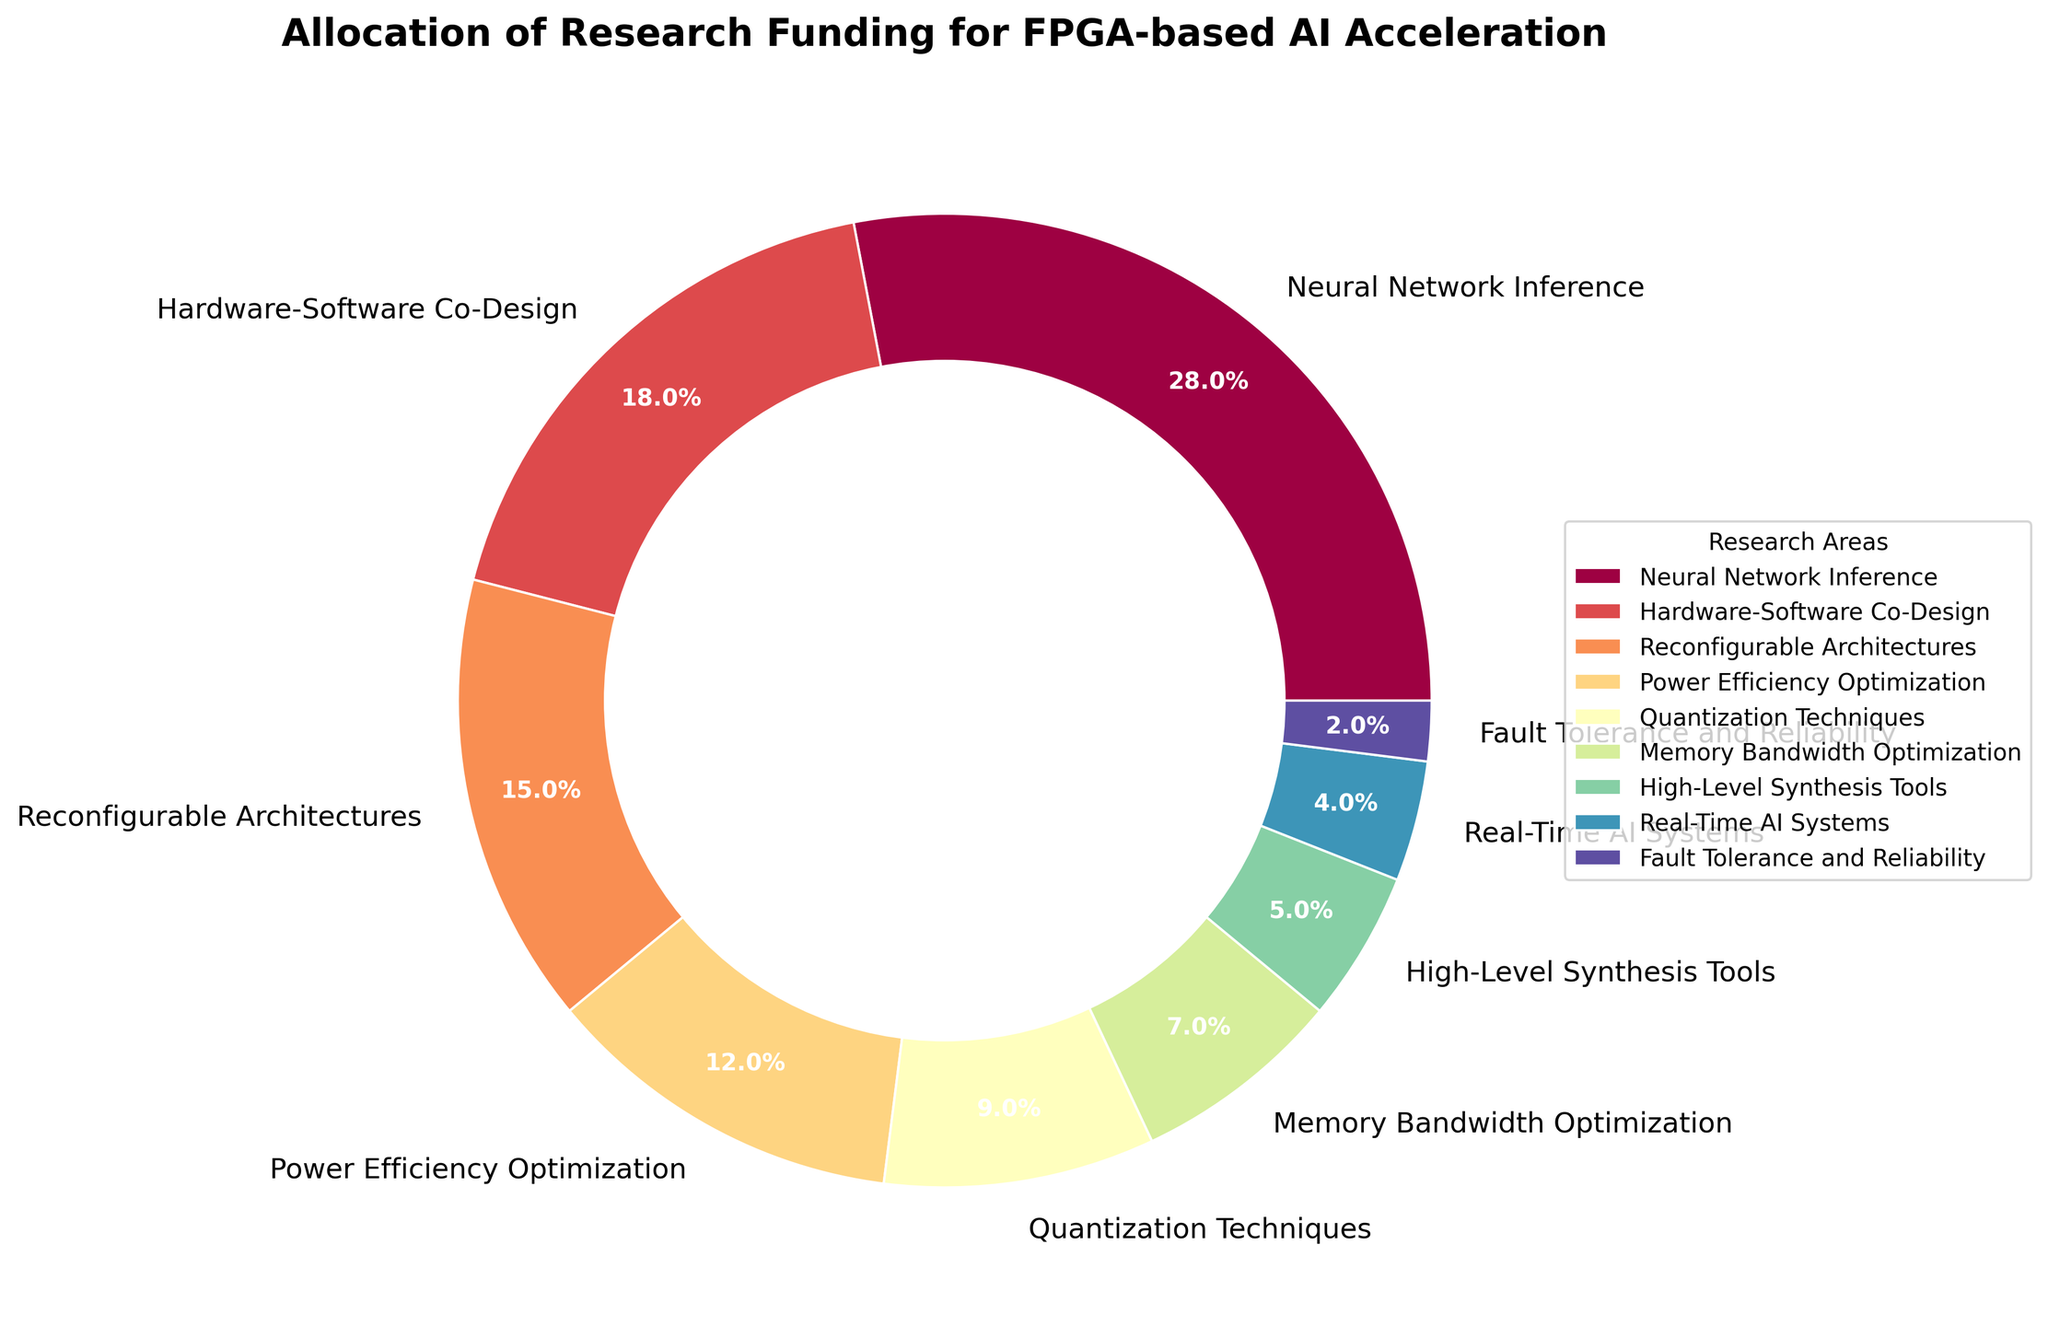what percentage of funding is allocated to Neural Network Inference? Locate the label "Neural Network Inference" on the pie chart and read the corresponding percentage.
Answer: 28% Which research areas combined receive more funding than Neural Network Inference? Add the percentages of the research areas and compare each sum to 28%. "Hardware-Software Co-Design" (18%) and "Reconfigurable Architectures" (15%) together receive 33%, which is greater than 28%. Individual areas "Power Efficiency Optimization" (12%) and below do not meet the requirement when summed alone or in pairs.
Answer: Hardware-Software Co-Design and Reconfigurable Architectures How much more funding is allocated to Memory Bandwidth Optimization compared to Fault Tolerance and Reliability? Subtract the percentage for "Fault Tolerance and Reliability" from that for "Memory Bandwidth Optimization": 7% - 2% = 5%.
Answer: 5% If Real-Time AI Systems and Fault Tolerance and Reliability received a combined total of 10%, how many percentage points are they currently receiving together? Sum the percentages for "Real-Time AI Systems" (4%) and "Fault Tolerance and Reliability" (2%): 4% + 2% = 6%. Compare this to the hypothetical 10%.
Answer: 6% Which research area has the smallest slice on the pie chart? Identify the smallest wedge visually, which belongs to the research area "Fault Tolerance and Reliability" (2%).
Answer: Fault Tolerance and Reliability What is the combined funding allocation percentage for the bottom three research areas? Sum the percentages for the three smallest areas: "High-Level Synthesis Tools" (5%), "Real-Time AI Systems" (4%), and "Fault Tolerance and Reliability" (2%): 5% + 4% + 2% = 11%.
Answer: 11% Is the percentage allocation to Quantization Techniques greater than that for Hardware-Software Co-Design? Compare the percentages of "Quantization Techniques" (9%) and "Hardware-Software Co-Design" (18%): 9% is less than 18%.
Answer: No Which research area has the third-highest funding allocation percentage? Order the research areas by their funding allocation. The top three are "Neural Network Inference" (28%), "Hardware-Software Co-Design" (18%), and "Reconfigurable Architectures" (15%).
Answer: Reconfigurable Architectures What’s the difference in funding allocation between the largest and smallest research areas? Subtract the percentage of the smallest area "Fault Tolerance and Reliability" (2%) from the largest area "Neural Network Inference" (28%): 28% - 2% = 26%.
Answer: 26% How do the combined percentages of Power Efficiency Optimization and Quantization Techniques compare to Neural Network Inference? Sum the percentages of "Power Efficiency Optimization" (12%) and "Quantization Techniques" (9%): 12% + 9% = 21%, which is less than "Neural Network Inference" (28%).
Answer: Less 